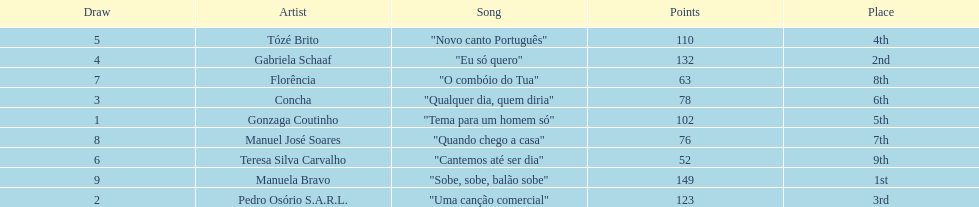Who was the last draw? Manuela Bravo. 